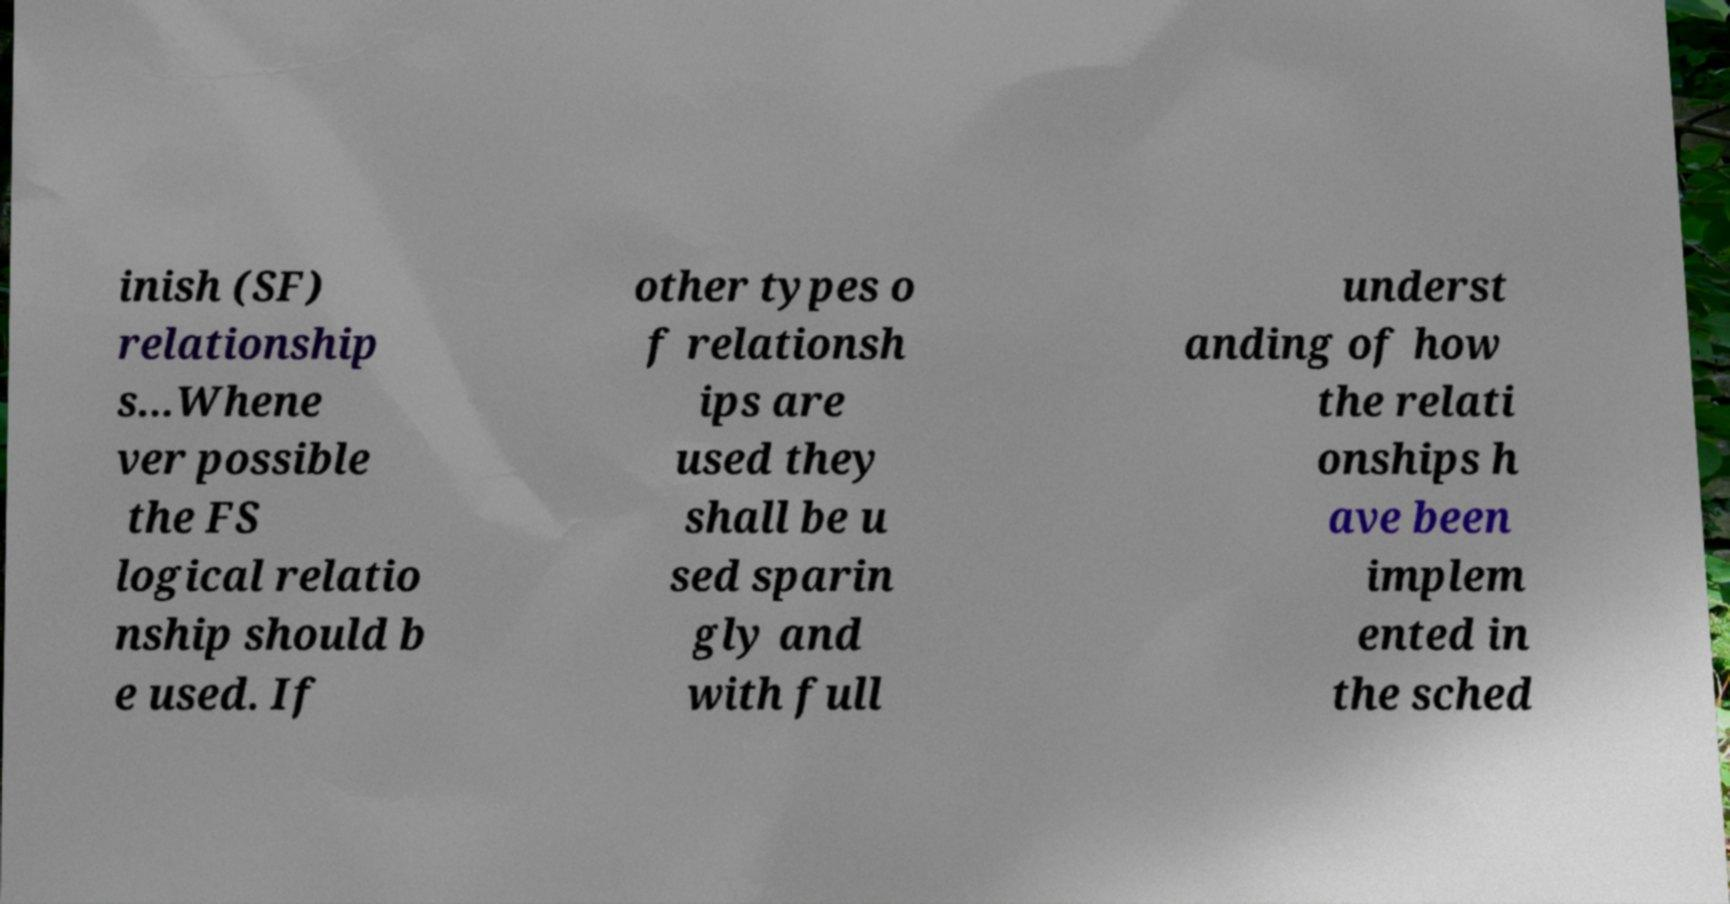Could you extract and type out the text from this image? inish (SF) relationship s...Whene ver possible the FS logical relatio nship should b e used. If other types o f relationsh ips are used they shall be u sed sparin gly and with full underst anding of how the relati onships h ave been implem ented in the sched 